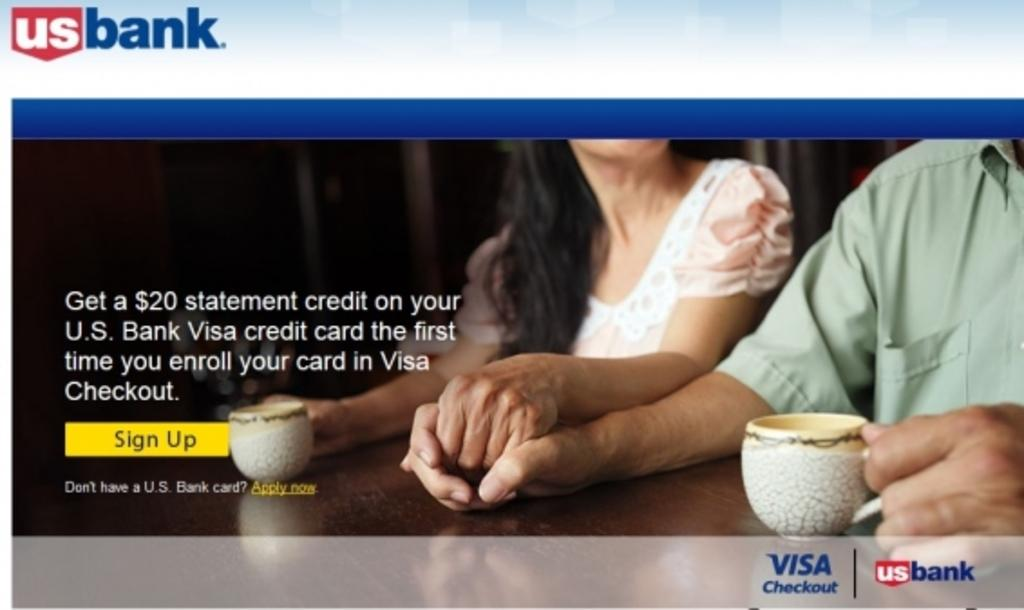What type of visual is depicted in the image? The image is a poster. Who can be seen in the poster? There is a man and a woman in the poster. What objects are present on the table in the poster? There are cups on a table in the poster. Is there any text included in the poster? Yes, there is text in the poster. What type of cake is being held by the man in the poster? There is no cake present in the poster; the man is not holding any cake. How many thumbs does the woman have in the poster? The number of thumbs cannot be determined from the image, as it is not possible to count them accurately. 